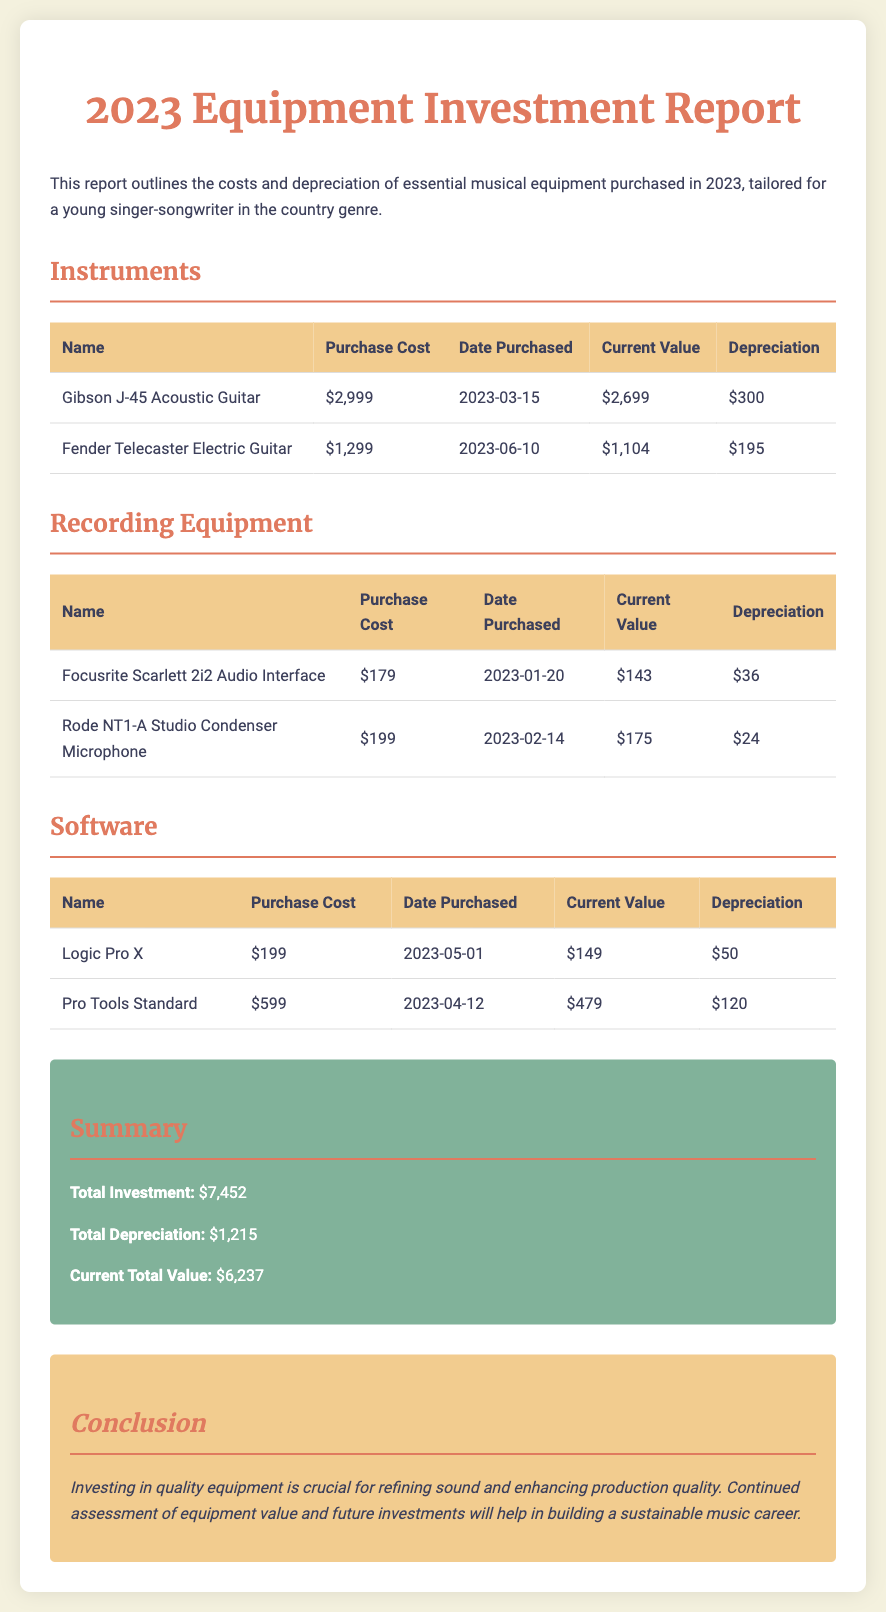What is the purchase cost of the Gibson J-45 Acoustic Guitar? The purchase cost of the Gibson J-45 Acoustic Guitar is listed in the Instruments section of the document.
Answer: $2,999 What is the current value of the Rode NT1-A Studio Condenser Microphone? The current value of the Rode NT1-A Studio Condenser Microphone is provided in the Recording Equipment section.
Answer: $175 When was Logic Pro X purchased? The date purchased for Logic Pro X is included under the Software section.
Answer: 2023-05-01 What is the total investment for equipment in 2023? The total investment is summarized in the Summary section, which aggregates all equipment costs.
Answer: $7,452 How much depreciation is recorded for the Fender Telecaster Electric Guitar? The depreciation for the Fender Telecaster Electric Guitar is detailed in the Instruments table.
Answer: $195 What is the total depreciation for all equipment? The total depreciation is presented in the Summary section of the report.
Answer: $1,215 Which item has the highest purchase cost? The item with the highest purchase cost is determined by comparing the costs of all listed equipment across the sections.
Answer: Gibson J-45 Acoustic Guitar What equipment was purchased on 2023-02-14? The date mentioned corresponds to the purchase of a specific item in the Recording Equipment section.
Answer: Rode NT1-A Studio Condenser Microphone What is the current total value of all equipment? The current total value is provided in the Summary section, reflecting the aggregated current values of all items.
Answer: $6,237 